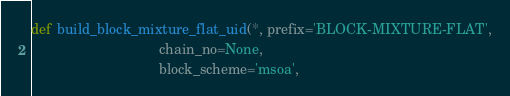Convert code to text. <code><loc_0><loc_0><loc_500><loc_500><_Python_>

def build_block_mixture_flat_uid(*, prefix='BLOCK-MIXTURE-FLAT',
                                 chain_no=None,
                                 block_scheme='msoa',</code> 